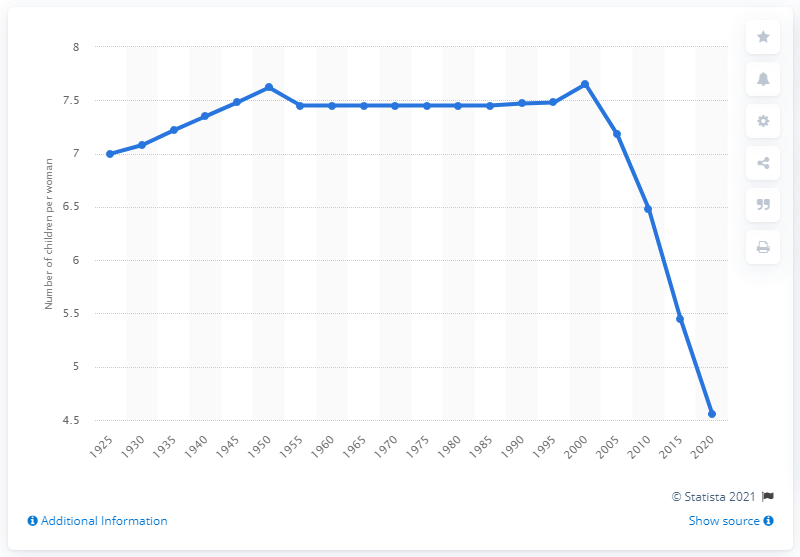Outline some significant characteristics in this image. Afghanistan's fertility rate dropped drastically in the year 2020. 